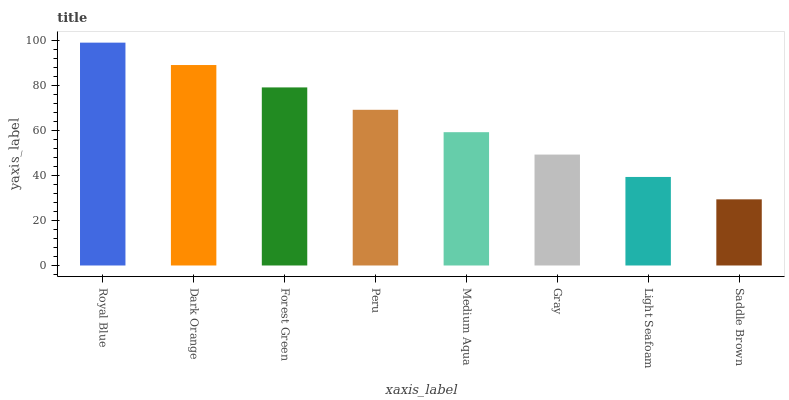Is Saddle Brown the minimum?
Answer yes or no. Yes. Is Royal Blue the maximum?
Answer yes or no. Yes. Is Dark Orange the minimum?
Answer yes or no. No. Is Dark Orange the maximum?
Answer yes or no. No. Is Royal Blue greater than Dark Orange?
Answer yes or no. Yes. Is Dark Orange less than Royal Blue?
Answer yes or no. Yes. Is Dark Orange greater than Royal Blue?
Answer yes or no. No. Is Royal Blue less than Dark Orange?
Answer yes or no. No. Is Peru the high median?
Answer yes or no. Yes. Is Medium Aqua the low median?
Answer yes or no. Yes. Is Dark Orange the high median?
Answer yes or no. No. Is Light Seafoam the low median?
Answer yes or no. No. 